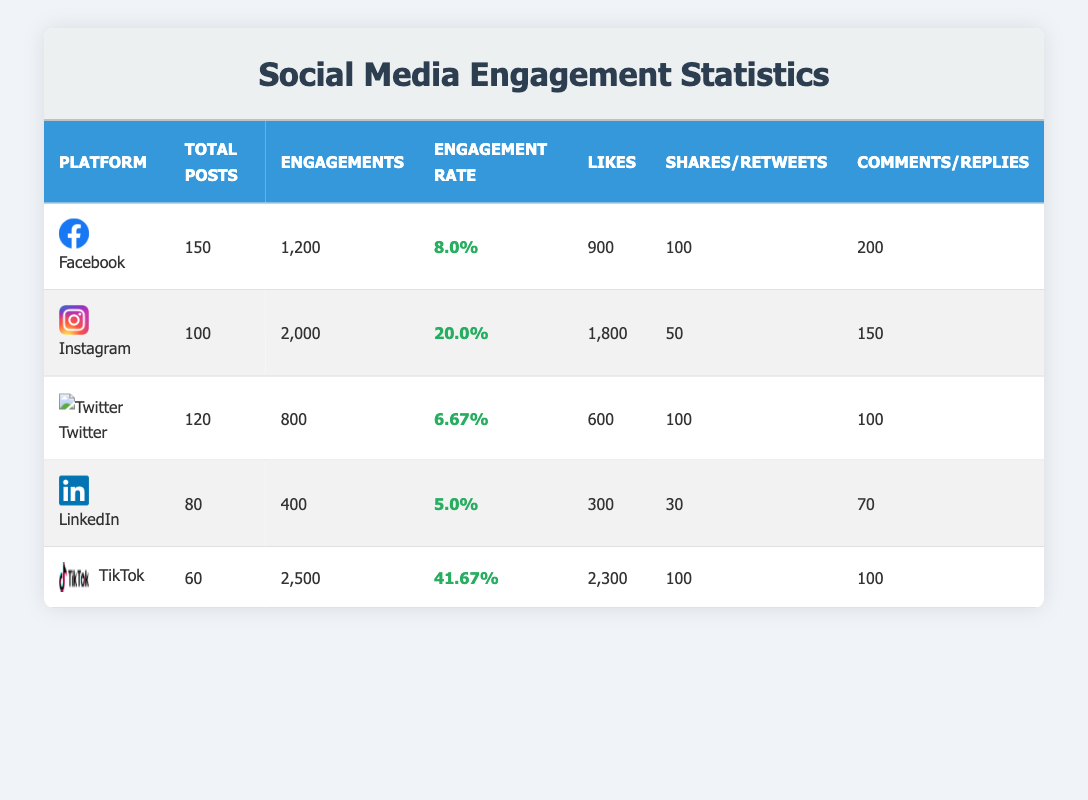What is the total number of likes on Instagram? From the Instagram row in the table, the number of likes is explicitly mentioned as 1800.
Answer: 1800 Which platform had the highest engagement rate? Looking through the engagement rates in the table, TikTok has an engagement rate of 41.67%, which is higher than all other platforms.
Answer: TikTok What is the average engagement rate across all platforms? The engagement rates are as follows: 8.0% for Facebook, 20.0% for Instagram, 6.67% for Twitter, 5.0% for LinkedIn, and 41.67% for TikTok. Adding these gives a total engagement rate of 81.34%, and dividing by 5 platforms results in an average engagement rate of 16.27%.
Answer: 16.27% Is the total number of engagements on LinkedIn greater than on Twitter? LinkedIn has 400 engagements while Twitter has 800 engagements. Comparing these two numbers shows that 400 is not greater than 800, so the statement is false.
Answer: No What is the total number of shares across all platforms? The shares for each platform are: Facebook (100), Instagram (50), Twitter (100), LinkedIn (30), and TikTok (100). Adding these values together gives a total of 100 + 50 + 100 + 30 + 100 = 380 shares.
Answer: 380 Which platform has the lowest number of comments? Looking at the comments in the table: Facebook has 200, Instagram has 150, Twitter has 100, LinkedIn has 70, and TikTok has 100. The lowest value among these is from LinkedIn with 70 comments.
Answer: LinkedIn How many more engagements did TikTok have compared to LinkedIn? TikTok had 2500 engagements, and LinkedIn had 400 engagements. To find the difference, subtract the engagements of LinkedIn from TikTok: 2500 - 400 = 2100.
Answer: 2100 Can you confirm if Twitter had more total posts than LinkedIn? Twitter has 120 total posts while LinkedIn has 80 total posts. Since 120 is greater than 80, the statement is true.
Answer: Yes 